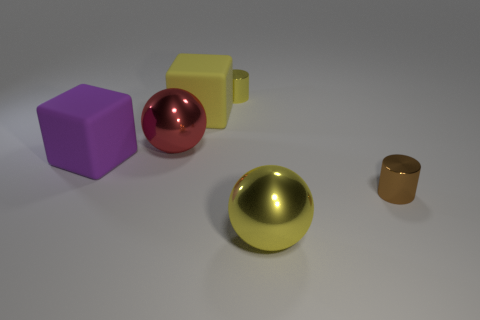What material is the big yellow thing left of the tiny yellow metallic cylinder behind the big metal sphere to the left of the tiny yellow metallic object?
Give a very brief answer. Rubber. What size is the red ball that is the same material as the brown cylinder?
Ensure brevity in your answer.  Large. Is the size of the brown object the same as the yellow metallic object left of the big yellow ball?
Your answer should be very brief. Yes. There is a big yellow object that is behind the metal sphere that is in front of the tiny brown cylinder; how many big yellow metal spheres are behind it?
Your answer should be compact. 0. There is a tiny yellow metallic cylinder; are there any tiny brown objects left of it?
Make the answer very short. No. The brown shiny object has what shape?
Your response must be concise. Cylinder. What shape is the big metal thing that is in front of the metal cylinder to the right of the yellow thing that is in front of the purple thing?
Offer a very short reply. Sphere. What number of other things are there of the same shape as the yellow matte object?
Your response must be concise. 1. What is the material of the tiny thing that is right of the object that is behind the big yellow rubber cube?
Make the answer very short. Metal. Are there any other things that have the same size as the red metal ball?
Offer a terse response. Yes. 